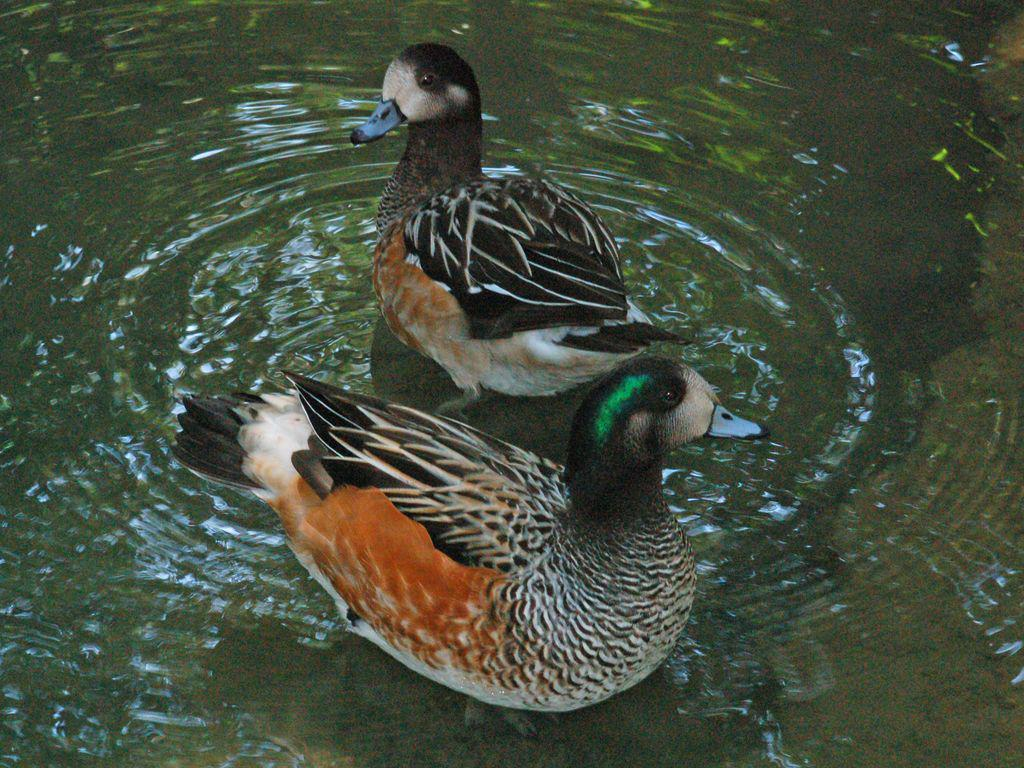What is the primary element visible in the image? There is water in the image. Are there any animals present in the image? Yes, there are two ducks on the water. What type of jar can be seen floating in the water in the image? There is no jar present in the image; it only features water and two ducks. 